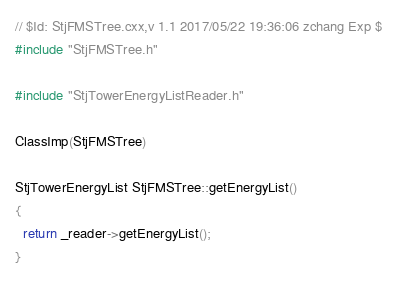Convert code to text. <code><loc_0><loc_0><loc_500><loc_500><_C++_>// $Id: StjFMSTree.cxx,v 1.1 2017/05/22 19:36:06 zchang Exp $
#include "StjFMSTree.h"

#include "StjTowerEnergyListReader.h"

ClassImp(StjFMSTree)

StjTowerEnergyList StjFMSTree::getEnergyList()
{
  return _reader->getEnergyList();
}
</code> 